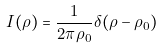Convert formula to latex. <formula><loc_0><loc_0><loc_500><loc_500>I ( \rho ) = \frac { 1 } { 2 \pi \rho _ { 0 } } \delta ( \rho - \rho _ { 0 } )</formula> 